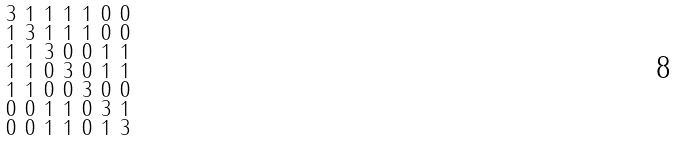<formula> <loc_0><loc_0><loc_500><loc_500>\begin{smallmatrix} 3 & 1 & 1 & 1 & 1 & 0 & 0 \\ 1 & 3 & 1 & 1 & 1 & 0 & 0 \\ 1 & 1 & 3 & 0 & 0 & 1 & 1 \\ 1 & 1 & 0 & 3 & 0 & 1 & 1 \\ 1 & 1 & 0 & 0 & 3 & 0 & 0 \\ 0 & 0 & 1 & 1 & 0 & 3 & 1 \\ 0 & 0 & 1 & 1 & 0 & 1 & 3 \end{smallmatrix}</formula> 